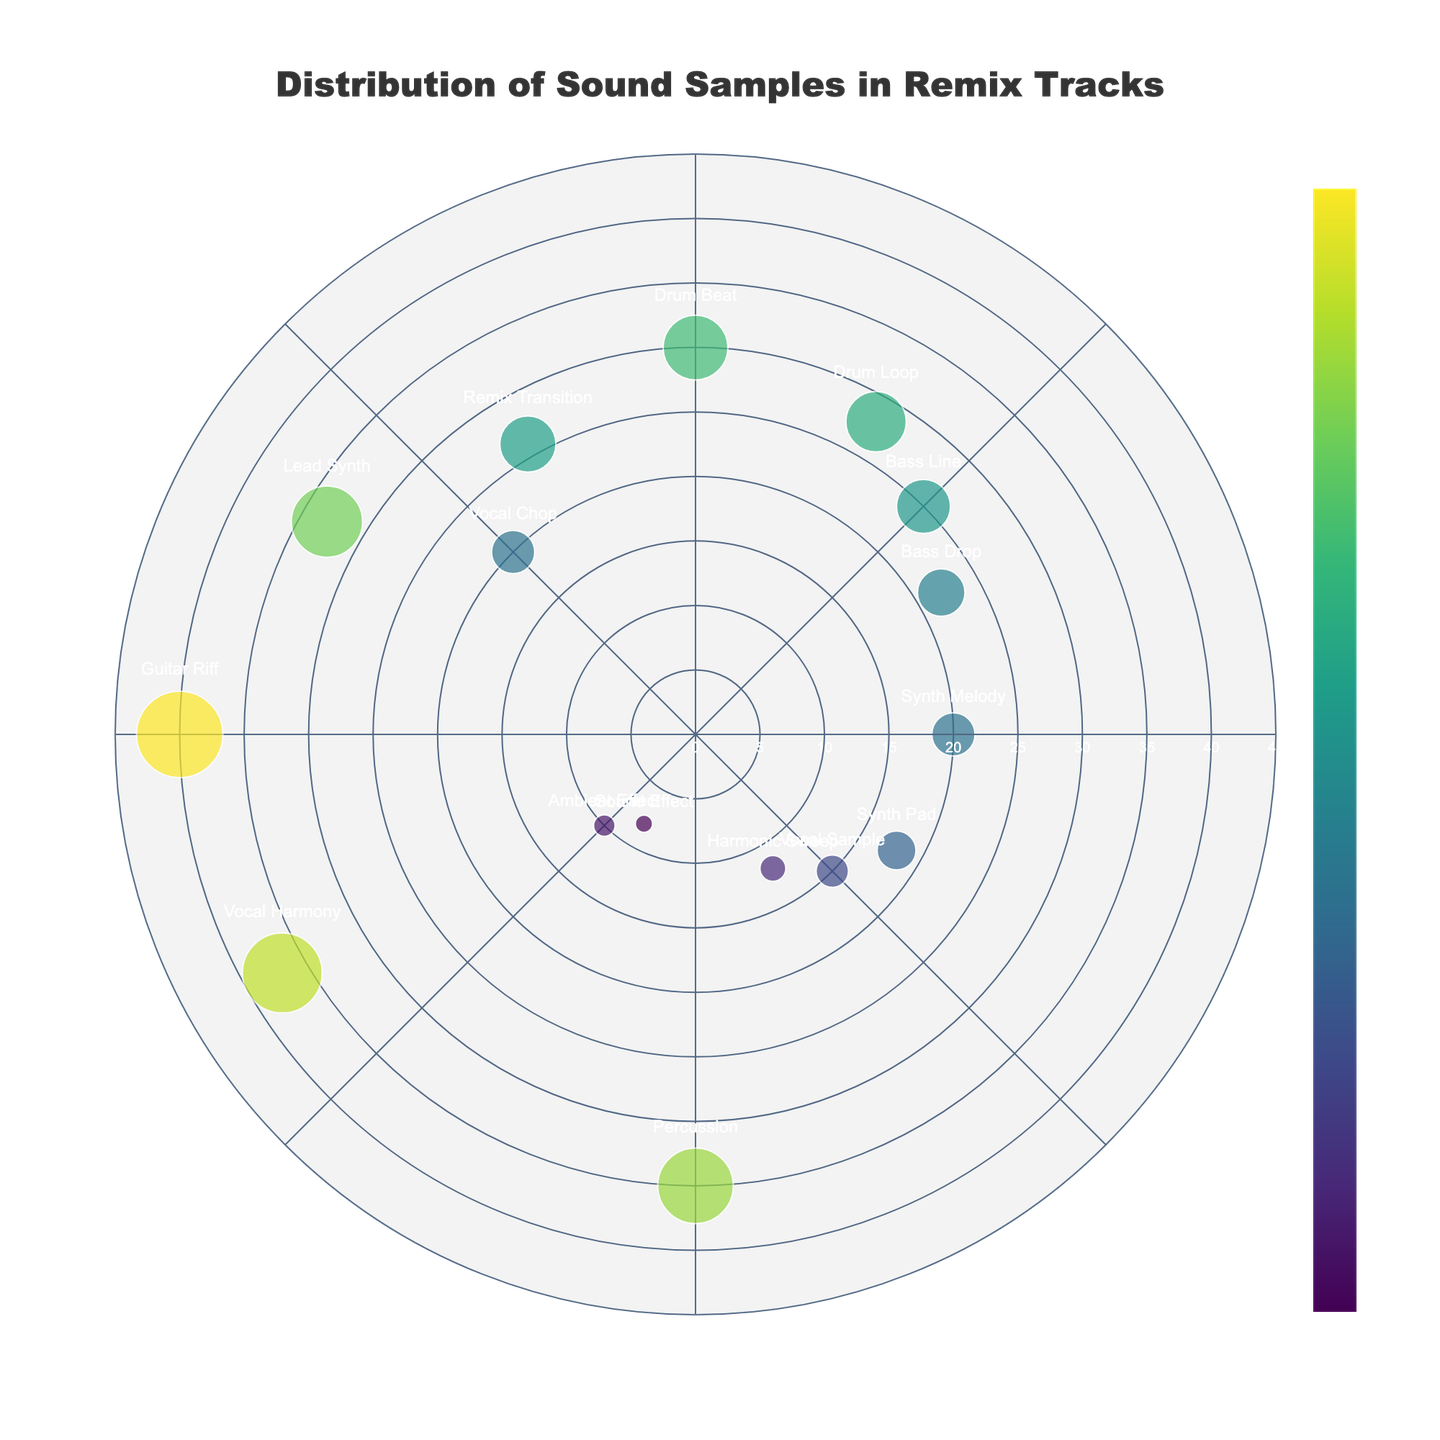what is the title of the figure? The title of the figure is displayed prominently at the top of the plot. To find the title, look at the center above the plot area.
Answer: Distribution of Sound Samples in Remix Tracks which sound type has the highest frequency? The frequency is represented by the "Radius" on the plot. The sound type with the largest radius (distance from the center) has the highest frequency.
Answer: Guitar Riff how many sound types have a frequency greater than 30? Identify the data points with a radius (frequency) greater than 30 by looking at the distance from the center. Count the number of these points.
Answer: 4 what are the sound types with a frequency of exactly 20? To find sound types with a frequency of exactly 20, look at the markers which are at a distance (radius) of 20 from the center.
Answer: Synth Melody, Vocal Chop what is the average frequency of Bass Line and Bass Drop? To find the average frequency of Bass Line and Bass Drop, first sum their frequencies: 25 + 22 = 47. Then divide by the number of sound types, which is 2.
Answer: 23.5 which sound type is located at 135 degrees? To find the sound type at a specific angle, locate the point at 135 degrees.
Answer: Vocal Sample compare the frequencies of Lead Synth and Remix Transition. Which one is higher? Find the markers for Lead Synth and Remix Transition and compare their distances (radii) from the center. The one farther from the center has the higher frequency.
Answer: Lead Synth which sound type has the smallest frequency? The smallest frequency corresponds to the shortest distance (smallest radius) from the center.
Answer: Sound Effect what is the total frequency of all sound types combined? Sum the radii (frequencies) of all the sound types to get the total frequency.
Answer: 371 identify all sound types that have a frequency between 20 and 30 inclusive. Look at the points whose radii fall between 20 and 30 inclusive, and list the corresponding sound types.
Answer: Bass Line, Drum Loop, Bass Drop, Lead Synth, Remix Transition 